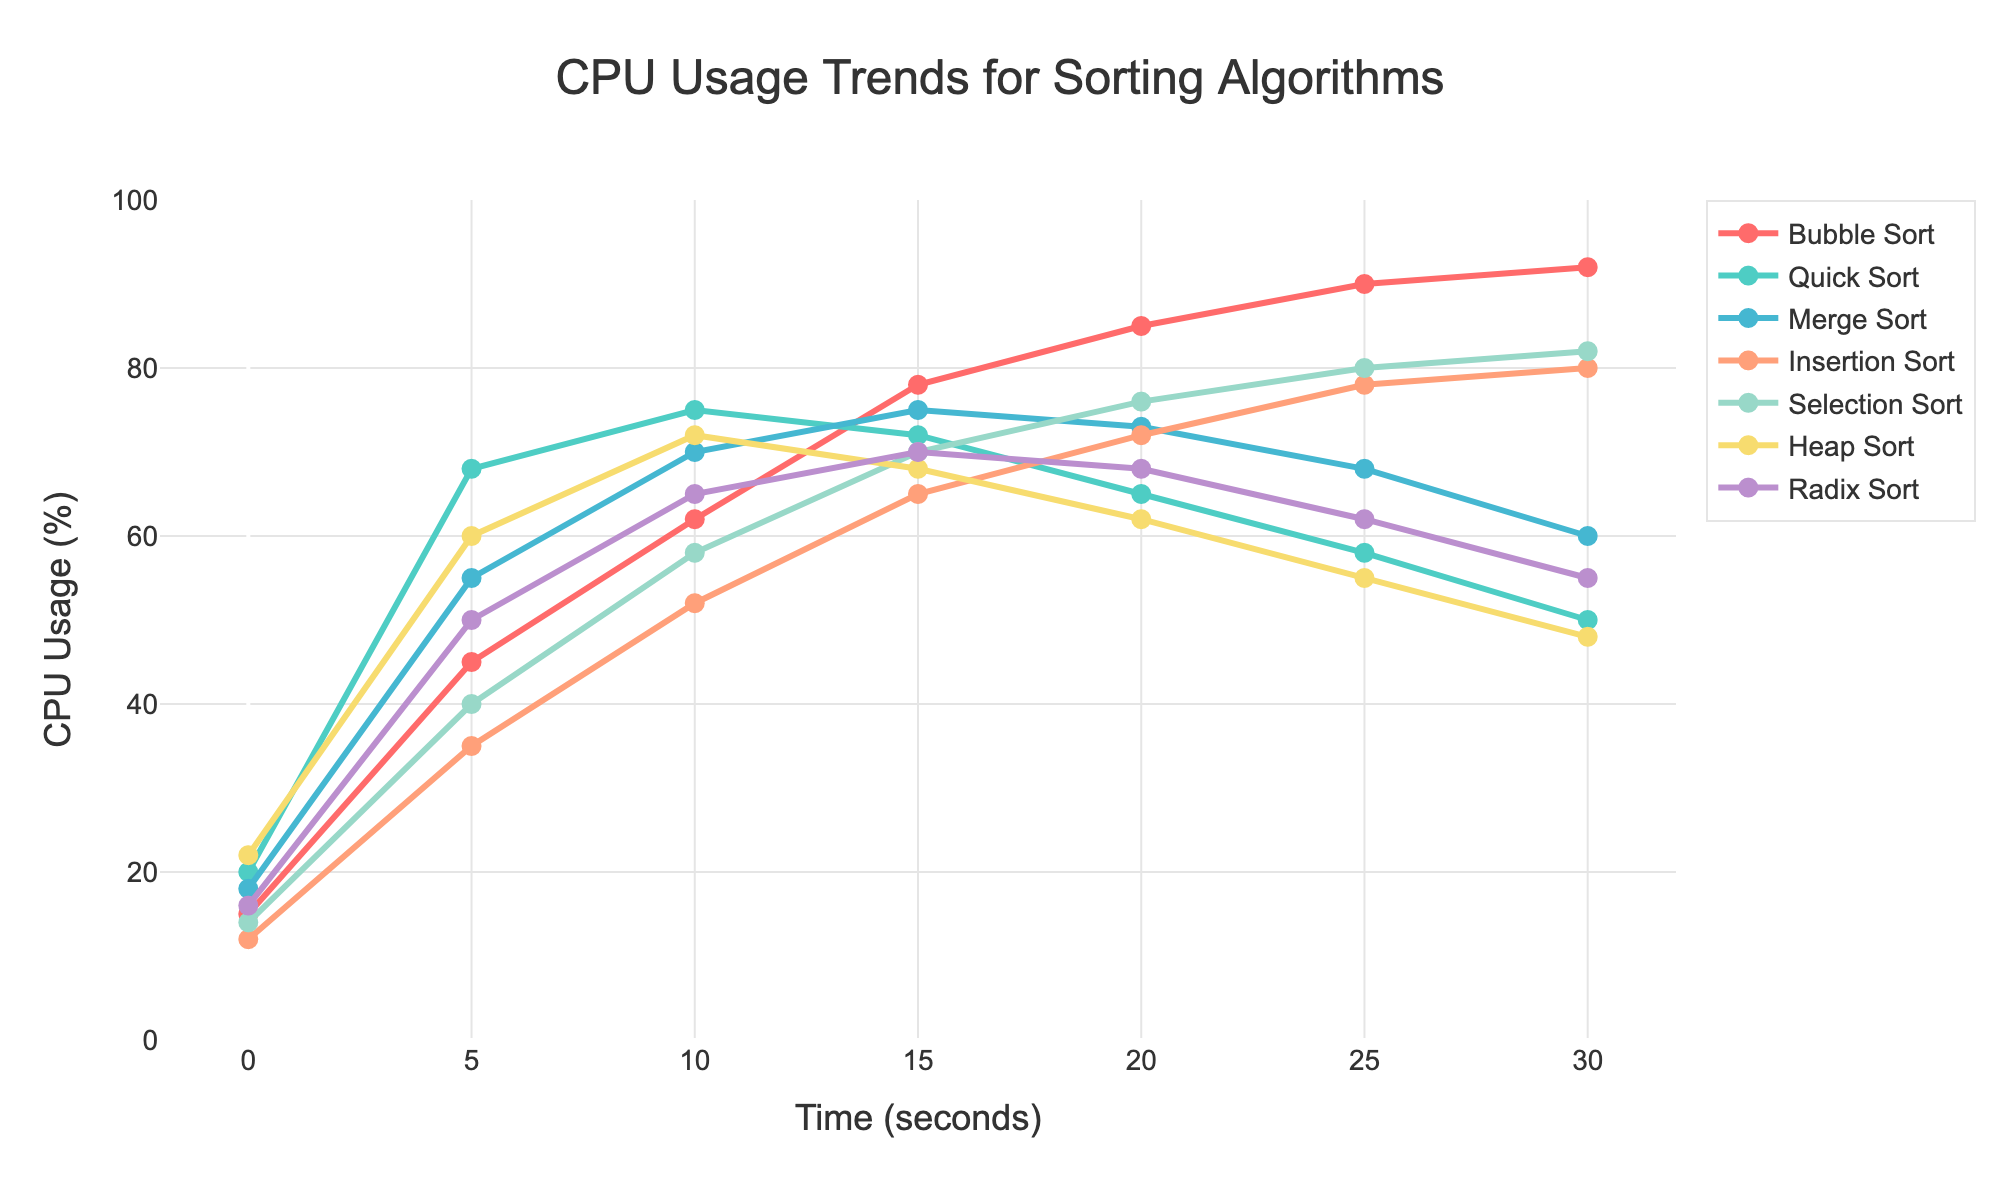What is the CPU usage of Bubble Sort at 25 seconds? Refer to the Bubble Sort line on the graph and check the CPU usage at the 25 seconds mark. The plotted point corresponds to 90%.
Answer: 90% Which algorithm shows the highest CPU usage at 10 seconds? Examine all the lines at the 10 seconds mark. Quick Sort has the highest point at that position, corresponding to 75%.
Answer: Quick Sort Compare the CPU usage of Quick Sort and Merge Sort at 20 seconds. Which one uses less CPU? Look at the points for both Quick Sort and Merge Sort at 20 seconds. Quick Sort is at 65%, and Merge Sort is at 73%. Hence, Quick Sort uses less CPU.
Answer: Quick Sort What is the color of the line representing Insertion Sort? Locate the Insertion Sort line on the graph. The line is colored green.
Answer: green Calculate the average CPU usage of Heap Sort from 0 seconds to 30 seconds. Add the CPU usage values of Heap Sort over all-time intervals: 22, 60, 72, 68, 62, 55, 48. The sum is 387. Divide by the number of points (7): 387/7 = 55.3.
Answer: 55.3 Which algorithm has the sharpest decrease in CPU usage from 10 seconds to 30 seconds? Compare the slopes of the lines from 10 to 30 seconds. Quick Sort decreases from 75% to 50%, a difference of 25%, which is the steepest decline.
Answer: Quick Sort What is the total CPU usage of Selection Sort over the entire duration? Sum the CPU usage values for Selection Sort: 14 + 40 + 58 + 70 + 76 + 80 + 82. This results in a total of 420%.
Answer: 420% Between Radix Sort and Insertion Sort, which algorithm uses more CPU at 15 seconds? Observe the CPU usage at 15 seconds for both Radix Sort and Insertion Sort. Radix Sort uses 70%, and Insertion Sort uses 65%. Thus, Radix Sort uses more CPU.
Answer: Radix Sort At what point in time does Bubble Sort reach its peak CPU usage? Check the Bubble Sort line for the highest point. The peak CPU usage for Bubble Sort is at 30 seconds with 92%.
Answer: 30 seconds Identify the algorithm with the lowest initial CPU usage and specify the value. Compare the CPU usage at 0 seconds for all algorithms. Insertion Sort has the lowest value at 12%.
Answer: Insertion Sort, 12% 